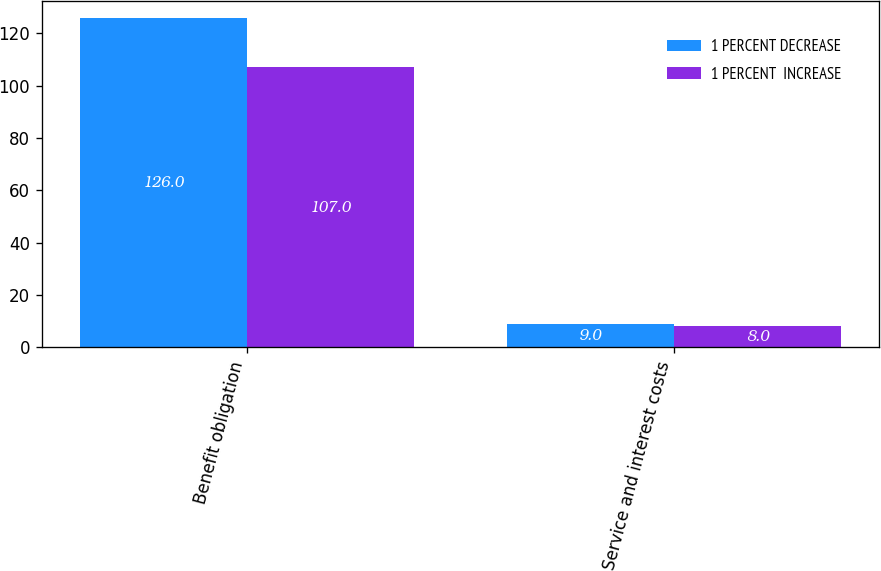<chart> <loc_0><loc_0><loc_500><loc_500><stacked_bar_chart><ecel><fcel>Benefit obligation<fcel>Service and interest costs<nl><fcel>1 PERCENT DECREASE<fcel>126<fcel>9<nl><fcel>1 PERCENT  INCREASE<fcel>107<fcel>8<nl></chart> 